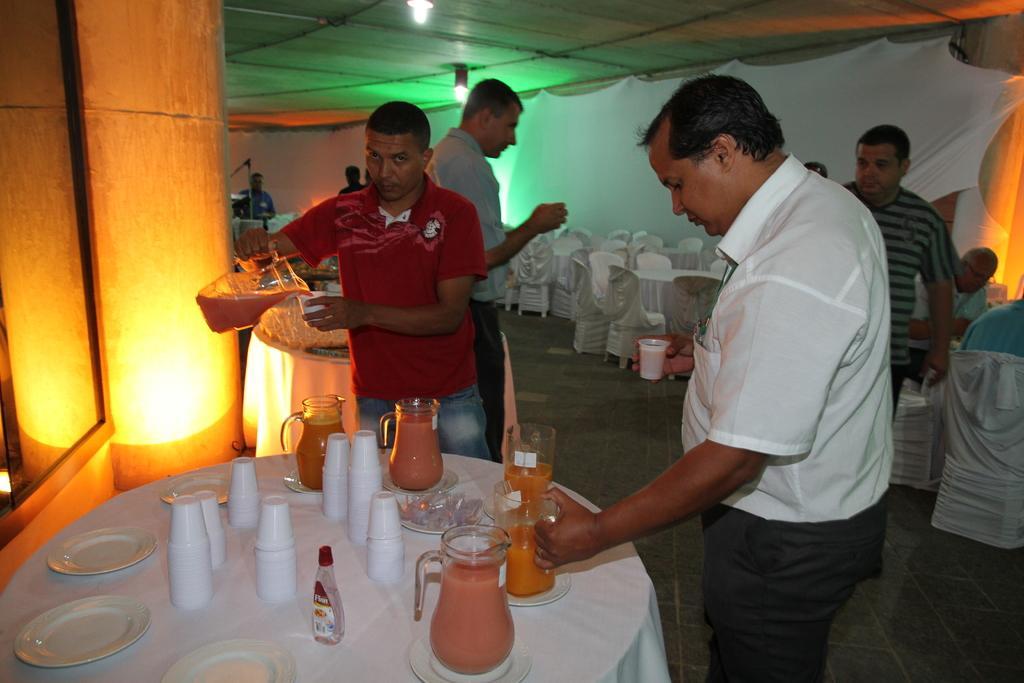Could you give a brief overview of what you see in this image? As we can see in the image, there is a wall, chairs, tables and few people standing on floor and on table there are glasses, mugs and plates. 